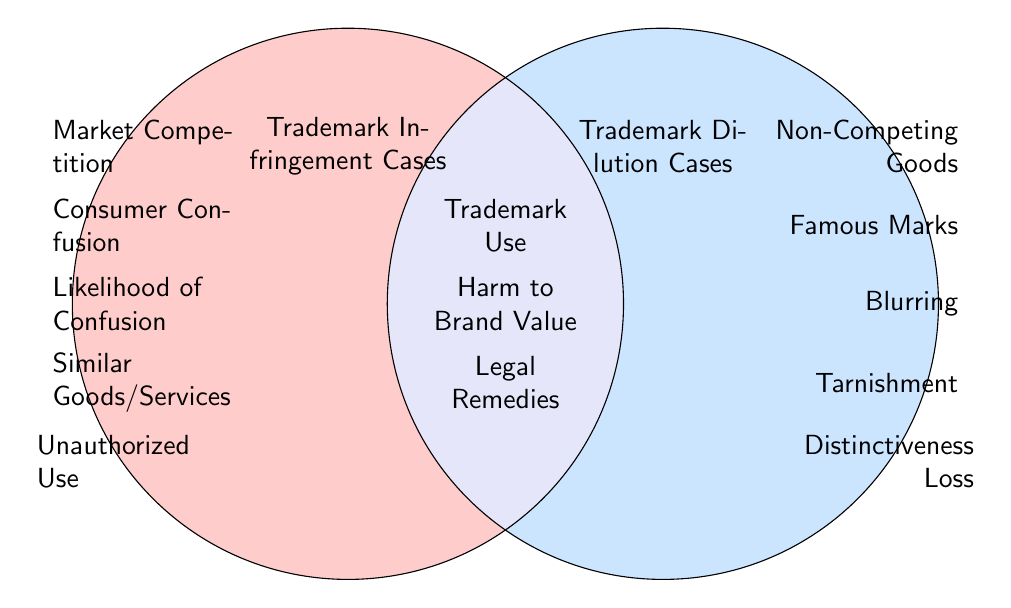What is the title of the left circle? The left circle is labeled "Trademark Infringement Cases," indicating it represents the category associated with trademark infringement.
Answer: Trademark Infringement Cases What is the title of the right circle? The right circle is labeled "Trademark Dilution Cases," indicating it represents the category associated with trademark dilution.
Answer: Trademark Dilution Cases Which factor is shared between both Trademark Infringement and Trademark Dilution Cases? The overlapping area of the two circles indicates that "Trademark Use" is a common factor relevant to both cases.
Answer: Trademark Use What are the legal implications listed in the intersection section? The intersection node includes "Harm to Brand Value" and "Legal Remedies," showing common legal considerations for both infringement and dilution.
Answer: Harm to Brand Value, Legal Remedies How many unique factors are related to Trademark Infringement? Counting the factors listed in the left circle, there are five unique factors tied to Trademark Infringement.
Answer: 5 What specific harm does "Tarnishment" represent? In the context of Trademark Dilution, "Tarnishment" refers to the negative association of a famous mark, harming its prestige.
Answer: Tarnishment Which concept does "Blurring" refer to? "Blurring" is depicted as a factor within Trademark Dilution, indicating a weakening of the mark's distinctiveness due to similar marks.
Answer: Blurring What is a characteristic of the goods related to Trademark Infringement? The factors in the left circle include "Similar Goods/Services," which indicates that Trademark Infringement often involves comparable products or services.
Answer: Similar Goods/Services What is one of the notable differences between Trademark Infringement and Trademark Dilution in terms of goods? The difference highlighted in the circles is that Trademark Dilution may occur with "Non-Competing Goods," whereas infringement generally involves competing products.
Answer: Non-Competing Goods 